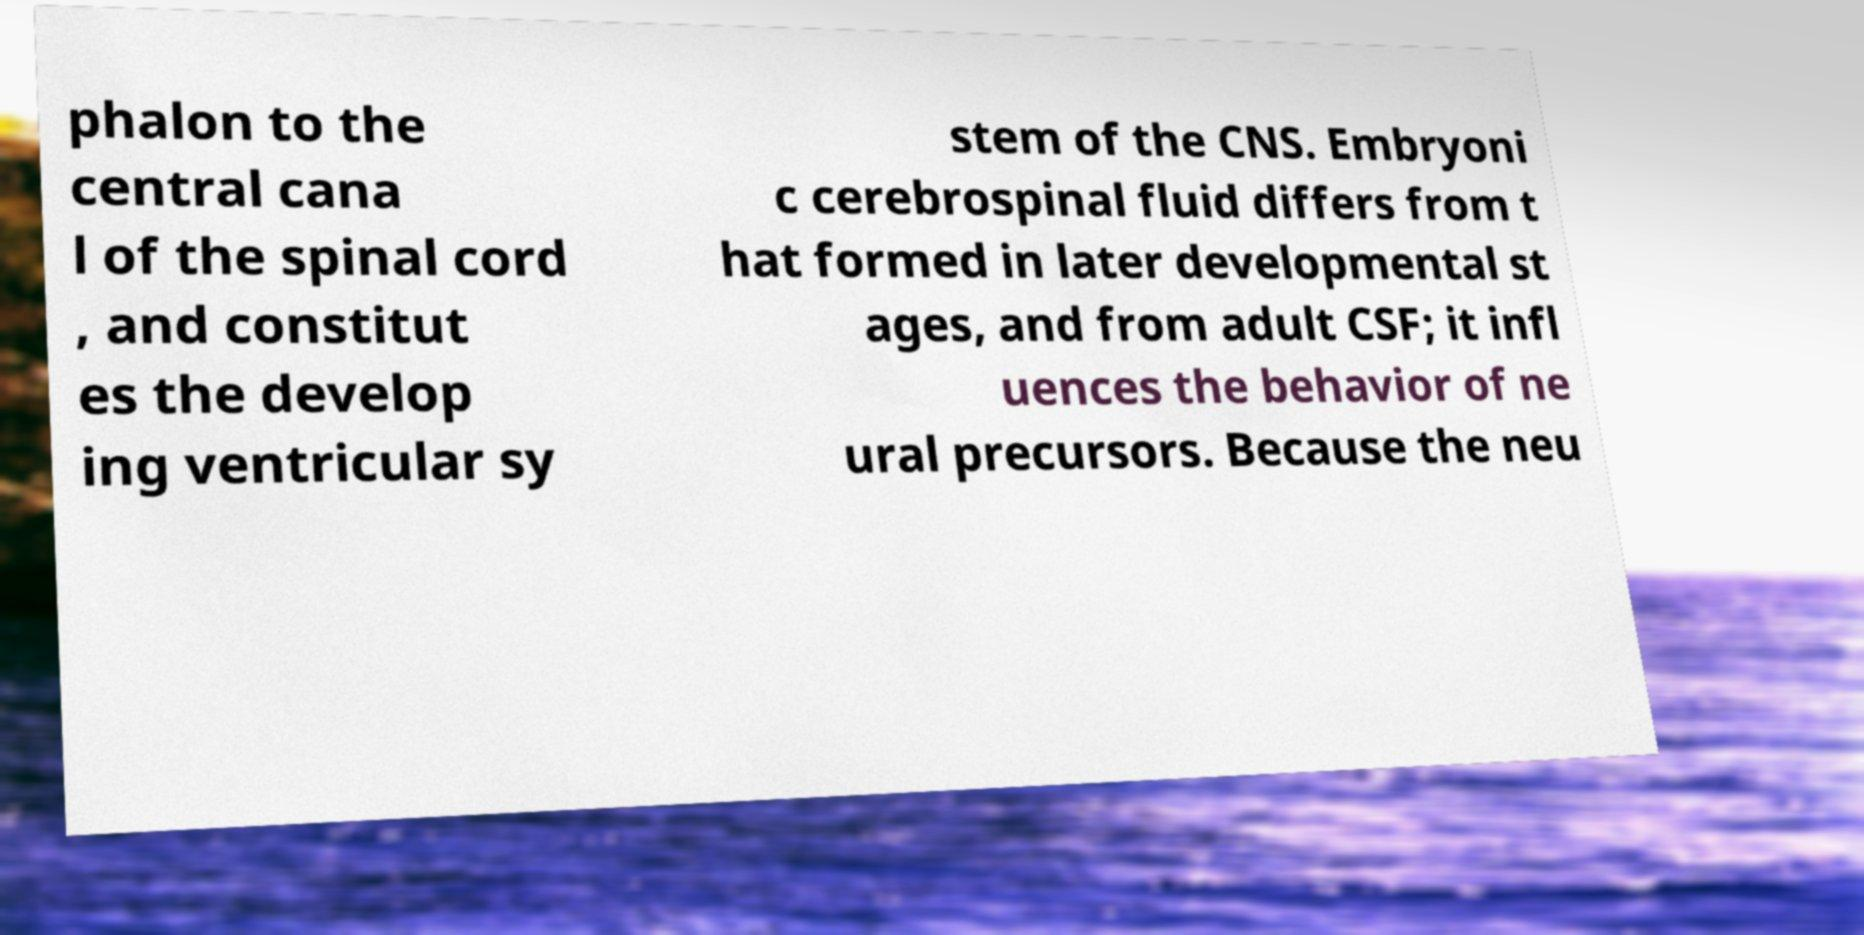There's text embedded in this image that I need extracted. Can you transcribe it verbatim? phalon to the central cana l of the spinal cord , and constitut es the develop ing ventricular sy stem of the CNS. Embryoni c cerebrospinal fluid differs from t hat formed in later developmental st ages, and from adult CSF; it infl uences the behavior of ne ural precursors. Because the neu 